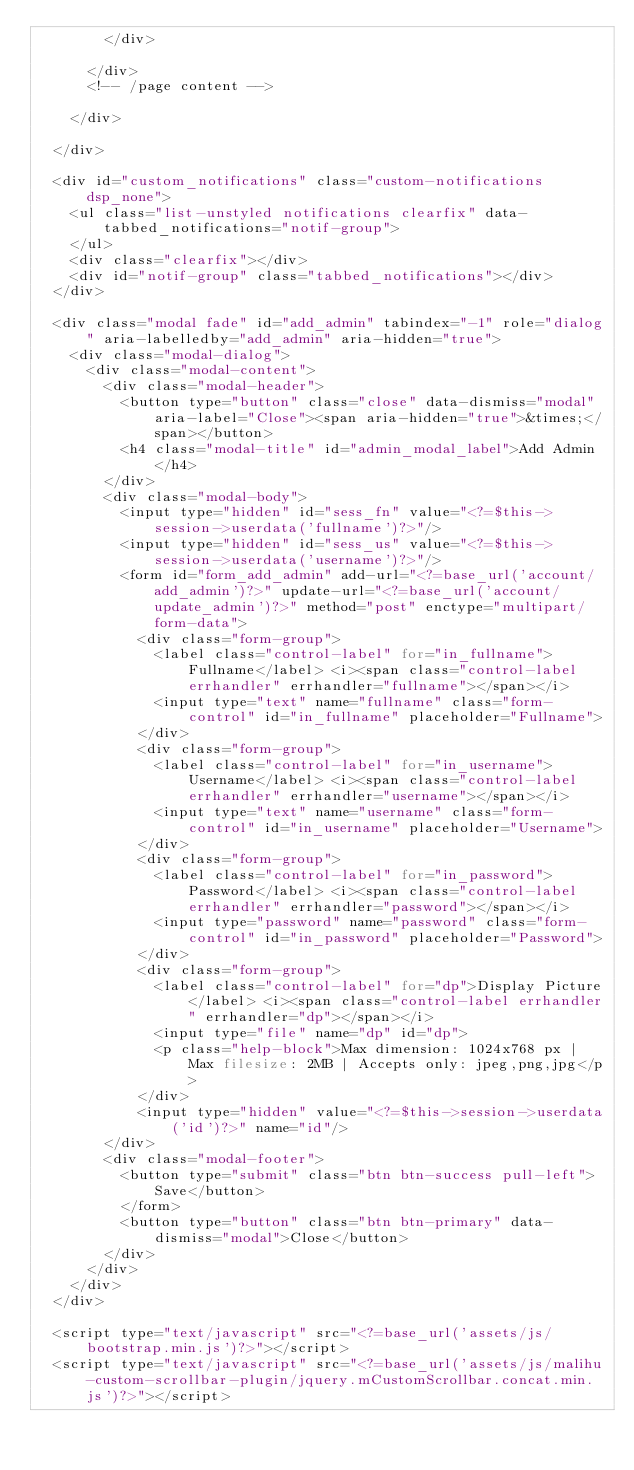Convert code to text. <code><loc_0><loc_0><loc_500><loc_500><_PHP_>				</div>
				
			</div>
			<!-- /page content -->

		</div>

	</div>

	<div id="custom_notifications" class="custom-notifications dsp_none">
		<ul class="list-unstyled notifications clearfix" data-tabbed_notifications="notif-group">
		</ul>
		<div class="clearfix"></div>
		<div id="notif-group" class="tabbed_notifications"></div>
	</div>

	<div class="modal fade" id="add_admin" tabindex="-1" role="dialog" aria-labelledby="add_admin" aria-hidden="true">
		<div class="modal-dialog">
			<div class="modal-content">
				<div class="modal-header">
					<button type="button" class="close" data-dismiss="modal" aria-label="Close"><span aria-hidden="true">&times;</span></button>
					<h4 class="modal-title" id="admin_modal_label">Add Admin</h4>
				</div>
				<div class="modal-body">
					<input type="hidden" id="sess_fn" value="<?=$this->session->userdata('fullname')?>"/>
					<input type="hidden" id="sess_us" value="<?=$this->session->userdata('username')?>"/>
					<form id="form_add_admin" add-url="<?=base_url('account/add_admin')?>" update-url="<?=base_url('account/update_admin')?>" method="post" enctype="multipart/form-data">
						<div class="form-group">
							<label class="control-label" for="in_fullname">Fullname</label> <i><span class="control-label errhandler" errhandler="fullname"></span></i>
							<input type="text" name="fullname" class="form-control" id="in_fullname" placeholder="Fullname">
						</div>
						<div class="form-group">
							<label class="control-label" for="in_username">Username</label> <i><span class="control-label errhandler" errhandler="username"></span></i>
							<input type="text" name="username" class="form-control" id="in_username" placeholder="Username">
						</div>
						<div class="form-group">
							<label class="control-label" for="in_password">Password</label> <i><span class="control-label errhandler" errhandler="password"></span></i>
							<input type="password" name="password" class="form-control" id="in_password" placeholder="Password">
						</div>
						<div class="form-group">
							<label class="control-label" for="dp">Display Picture</label> <i><span class="control-label errhandler" errhandler="dp"></span></i>
							<input type="file" name="dp" id="dp">
							<p class="help-block">Max dimension: 1024x768 px | Max filesize: 2MB | Accepts only: jpeg,png,jpg</p>
						</div>
						<input type="hidden" value="<?=$this->session->userdata('id')?>" name="id"/>
				</div>
				<div class="modal-footer">
					<button type="submit" class="btn btn-success pull-left">Save</button>
					</form>
					<button type="button" class="btn btn-primary" data-dismiss="modal">Close</button>
				</div>
			</div>
		</div>
	</div>

	<script type="text/javascript" src="<?=base_url('assets/js/bootstrap.min.js')?>"></script>
	<script type="text/javascript" src="<?=base_url('assets/js/malihu-custom-scrollbar-plugin/jquery.mCustomScrollbar.concat.min.js')?>"></script></code> 